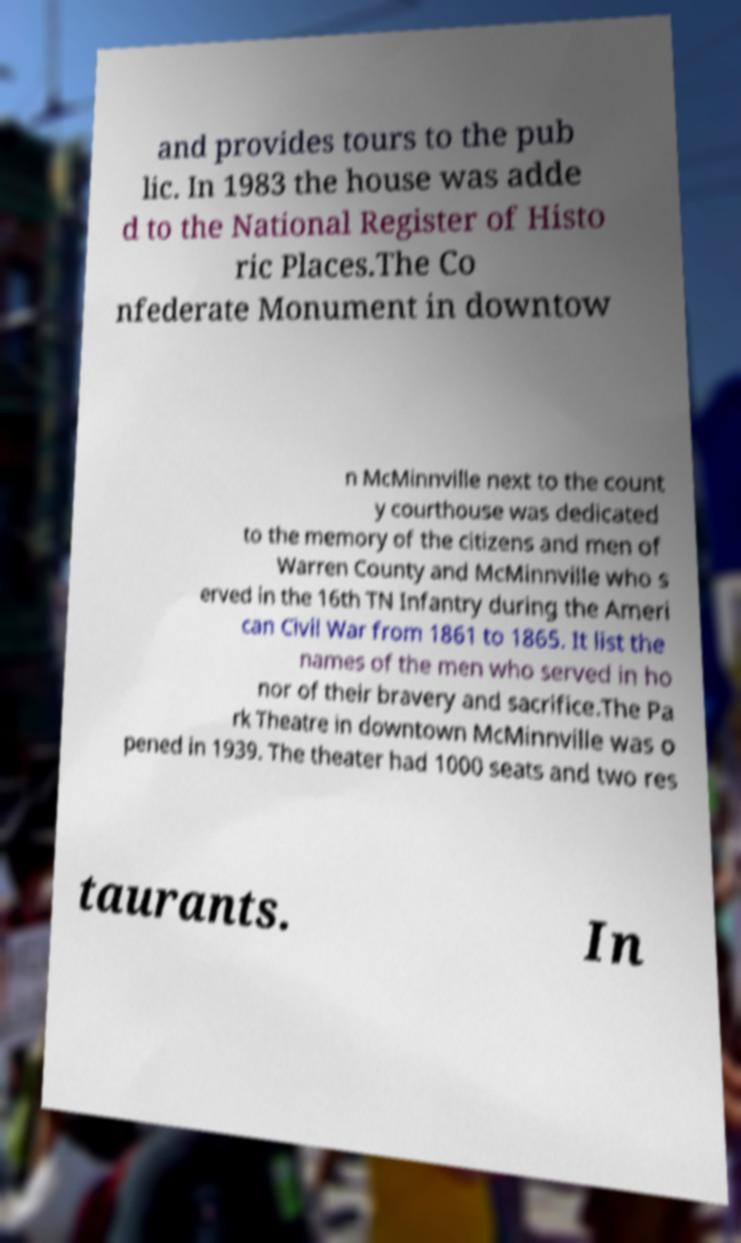Please identify and transcribe the text found in this image. and provides tours to the pub lic. In 1983 the house was adde d to the National Register of Histo ric Places.The Co nfederate Monument in downtow n McMinnville next to the count y courthouse was dedicated to the memory of the citizens and men of Warren County and McMinnville who s erved in the 16th TN Infantry during the Ameri can Civil War from 1861 to 1865. It list the names of the men who served in ho nor of their bravery and sacrifice.The Pa rk Theatre in downtown McMinnville was o pened in 1939. The theater had 1000 seats and two res taurants. In 